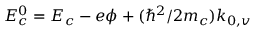Convert formula to latex. <formula><loc_0><loc_0><loc_500><loc_500>E _ { c } ^ { 0 } = E _ { c } - e \phi + ( \hbar { ^ } { 2 } / 2 m _ { c } ) k _ { 0 , v }</formula> 